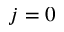<formula> <loc_0><loc_0><loc_500><loc_500>j = 0</formula> 